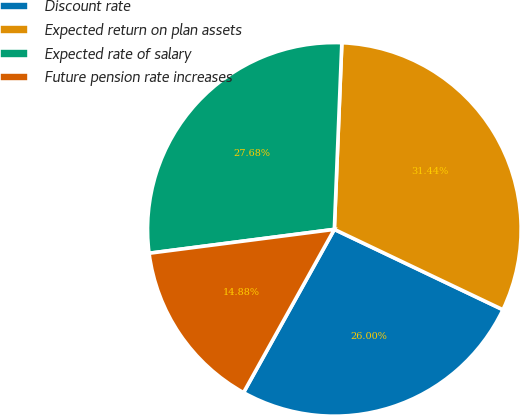Convert chart. <chart><loc_0><loc_0><loc_500><loc_500><pie_chart><fcel>Discount rate<fcel>Expected return on plan assets<fcel>Expected rate of salary<fcel>Future pension rate increases<nl><fcel>26.0%<fcel>31.44%<fcel>27.68%<fcel>14.88%<nl></chart> 